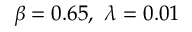Convert formula to latex. <formula><loc_0><loc_0><loc_500><loc_500>\beta = 0 . 6 5 , \ \lambda = 0 . 0 1</formula> 